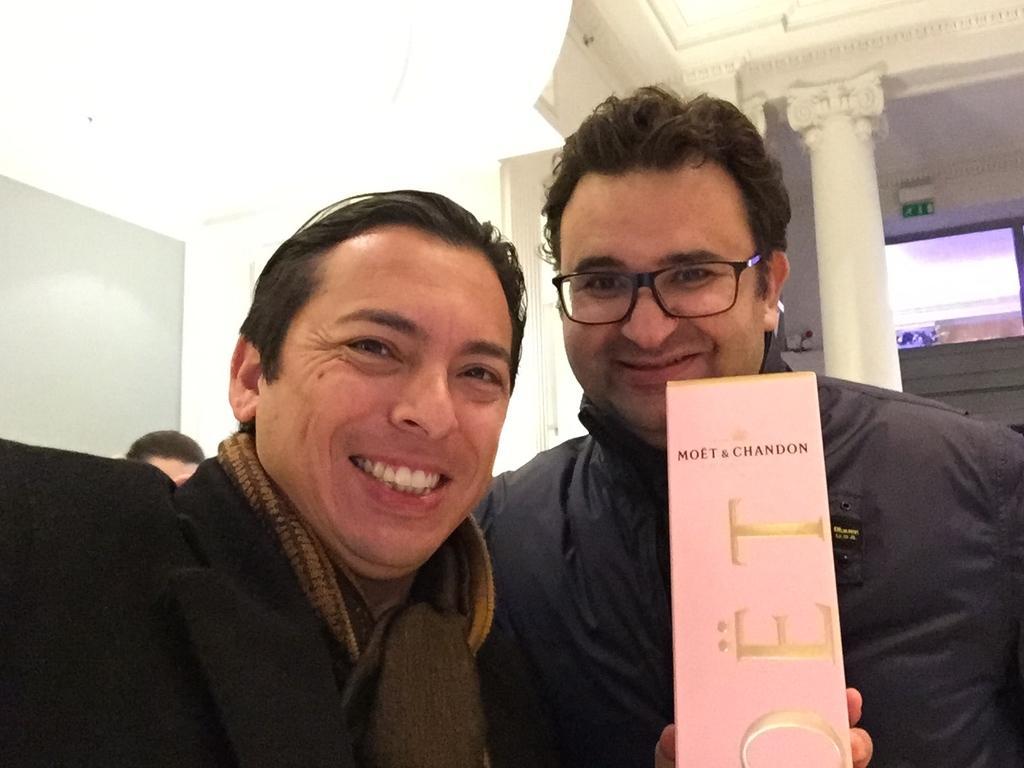Could you give a brief overview of what you see in this image? In the image there are two men, the first person is holding some item in his hand, both of them are smiling and behind them there is some other person and on the right side in the background there is a pillar and behind the pillar there is a wall. 